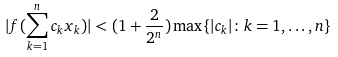<formula> <loc_0><loc_0><loc_500><loc_500>| f ( \sum _ { k = 1 } ^ { n } c _ { k } x _ { k } ) | < ( 1 + \frac { 2 } { 2 ^ { n } } ) \max \{ | c _ { k } | \colon k = 1 , \dots , n \}</formula> 